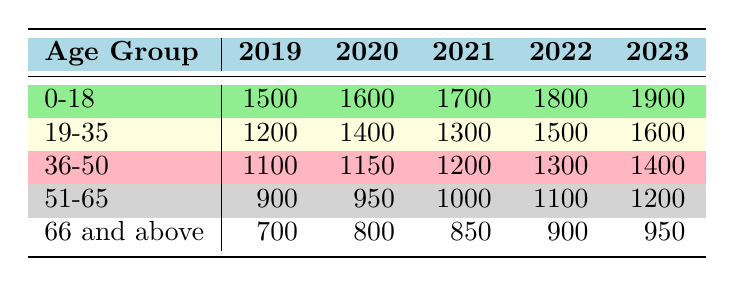What is the total number of patient visits for the age group 0-18 from 2019 to 2023? To find the total, we need to sum the visit counts for the age group 0-18 across all five years: 1500 (2019) + 1600 (2020) + 1700 (2021) + 1800 (2022) + 1900 (2023) = 10500.
Answer: 10500 What year had the highest number of patient visits for the age group 66 and above? Looking at the row for the age group 66 and above, the visits per year are: 700 (2019), 800 (2020), 850 (2021), 900 (2022), and 950 (2023). The highest value is 950, which occurred in 2023.
Answer: 2023 Is the visit count for the age group 19-35 lower in 2021 compared to 2020? In the table, the visit count for 2020 is 1400 and for 2021 is 1300. Since 1300 is less than 1400, the statement is true.
Answer: Yes What is the average number of patient visits for the age group 51-65 over the last five years? To calculate the average, we add the visit counts: 900 (2019) + 950 (2020) + 1000 (2021) + 1100 (2022) + 1200 (2023) = 4150. Dividing by the number of years (5), we get 4150/5 = 830.
Answer: 830 Which age group experienced the highest growth in patient visits from 2019 to 2023? We need to calculate the difference in visit counts for each age group from 2019 to 2023. For 0-18: 1900 - 1500 = 400, 19-35: 1600 - 1200 = 400, 36-50: 1400 - 1100 = 300, 51-65: 1200 - 900 = 300, and 66 and above: 950 - 700 = 250. The highest growth is 400, shared by age groups 0-18 and 19-35.
Answer: 0-18 and 19-35 Was there a decrease in patient visits for the age group 36-50 from 2021 to 2022? For the age group 36-50, the visit count in 2021 is 1200 and in 2022 it is 1300. Since 1300 is greater than 1200, there was no decrease.
Answer: No 